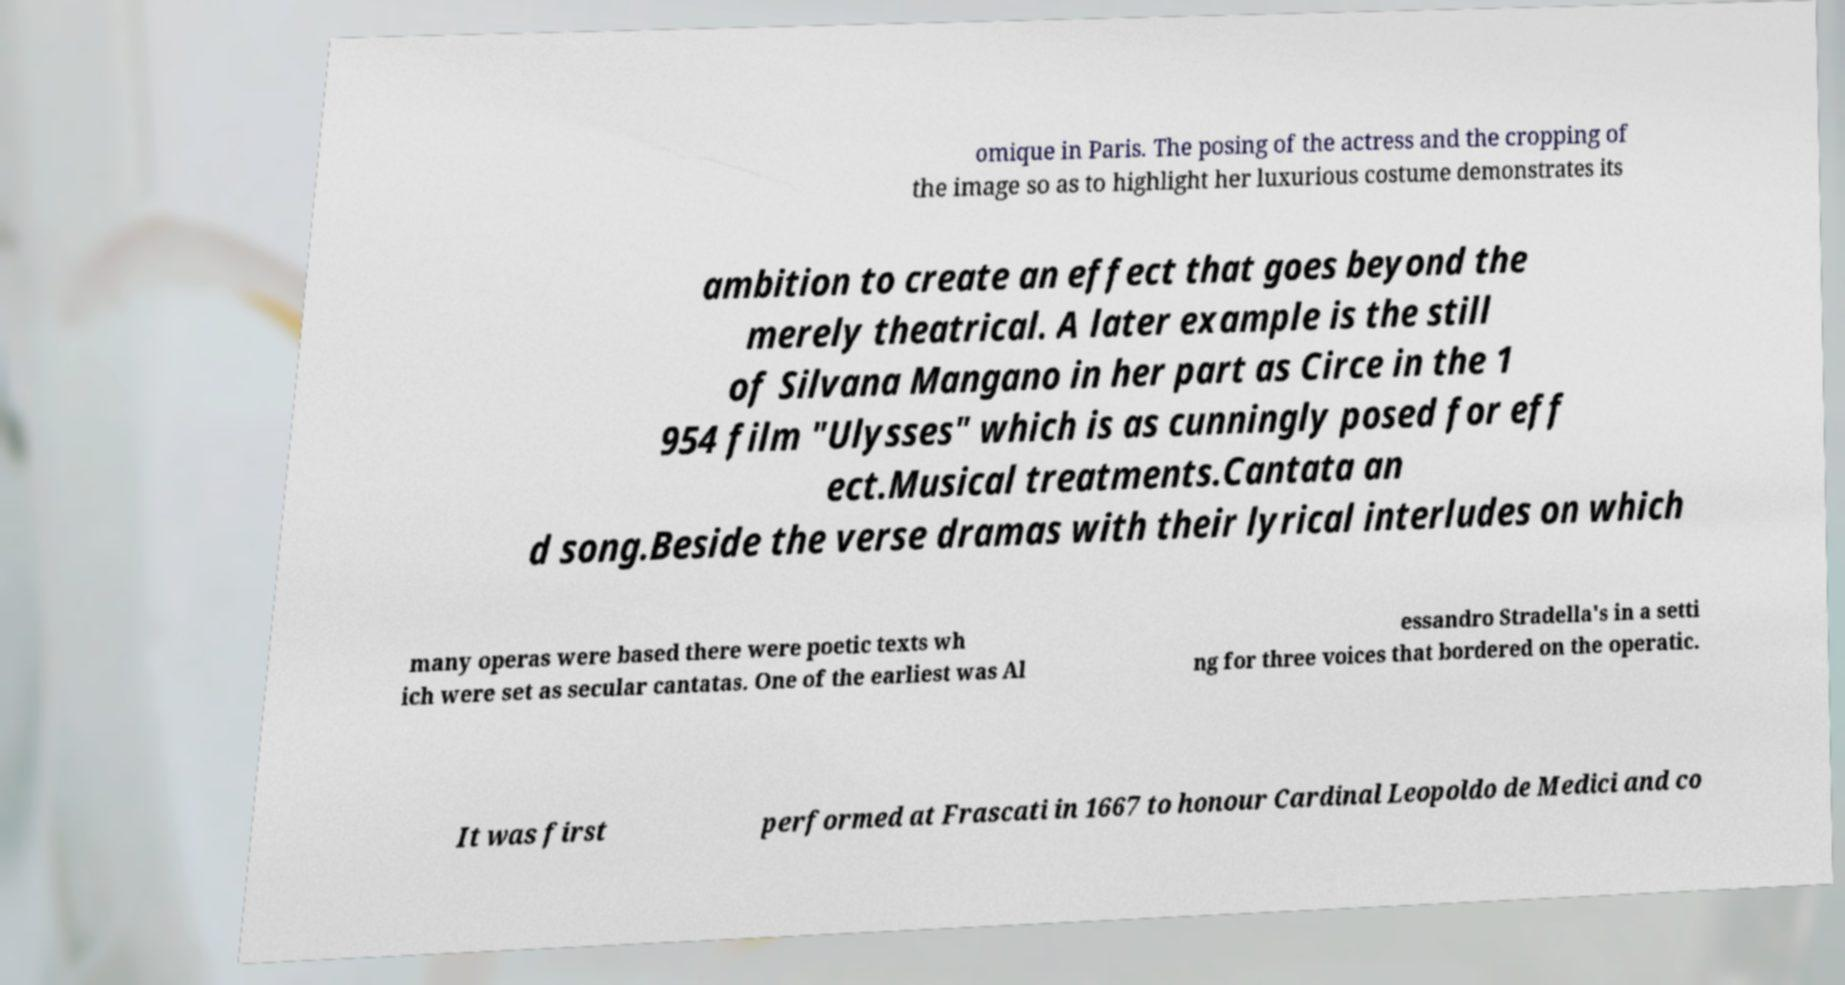Could you extract and type out the text from this image? omique in Paris. The posing of the actress and the cropping of the image so as to highlight her luxurious costume demonstrates its ambition to create an effect that goes beyond the merely theatrical. A later example is the still of Silvana Mangano in her part as Circe in the 1 954 film "Ulysses" which is as cunningly posed for eff ect.Musical treatments.Cantata an d song.Beside the verse dramas with their lyrical interludes on which many operas were based there were poetic texts wh ich were set as secular cantatas. One of the earliest was Al essandro Stradella's in a setti ng for three voices that bordered on the operatic. It was first performed at Frascati in 1667 to honour Cardinal Leopoldo de Medici and co 